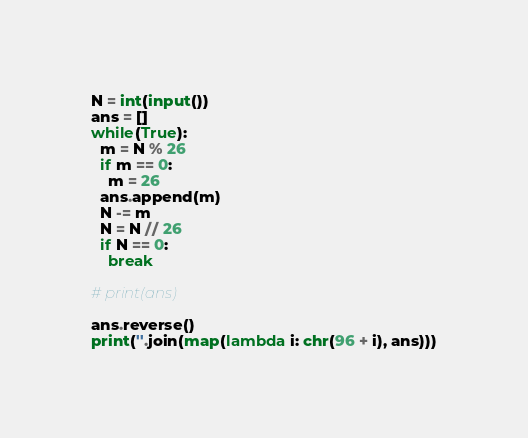<code> <loc_0><loc_0><loc_500><loc_500><_Python_>N = int(input())
ans = []
while(True):
  m = N % 26
  if m == 0:
    m = 26
  ans.append(m)
  N -= m
  N = N // 26
  if N == 0:
    break

# print(ans)

ans.reverse()
print(''.join(map(lambda i: chr(96 + i), ans)))</code> 